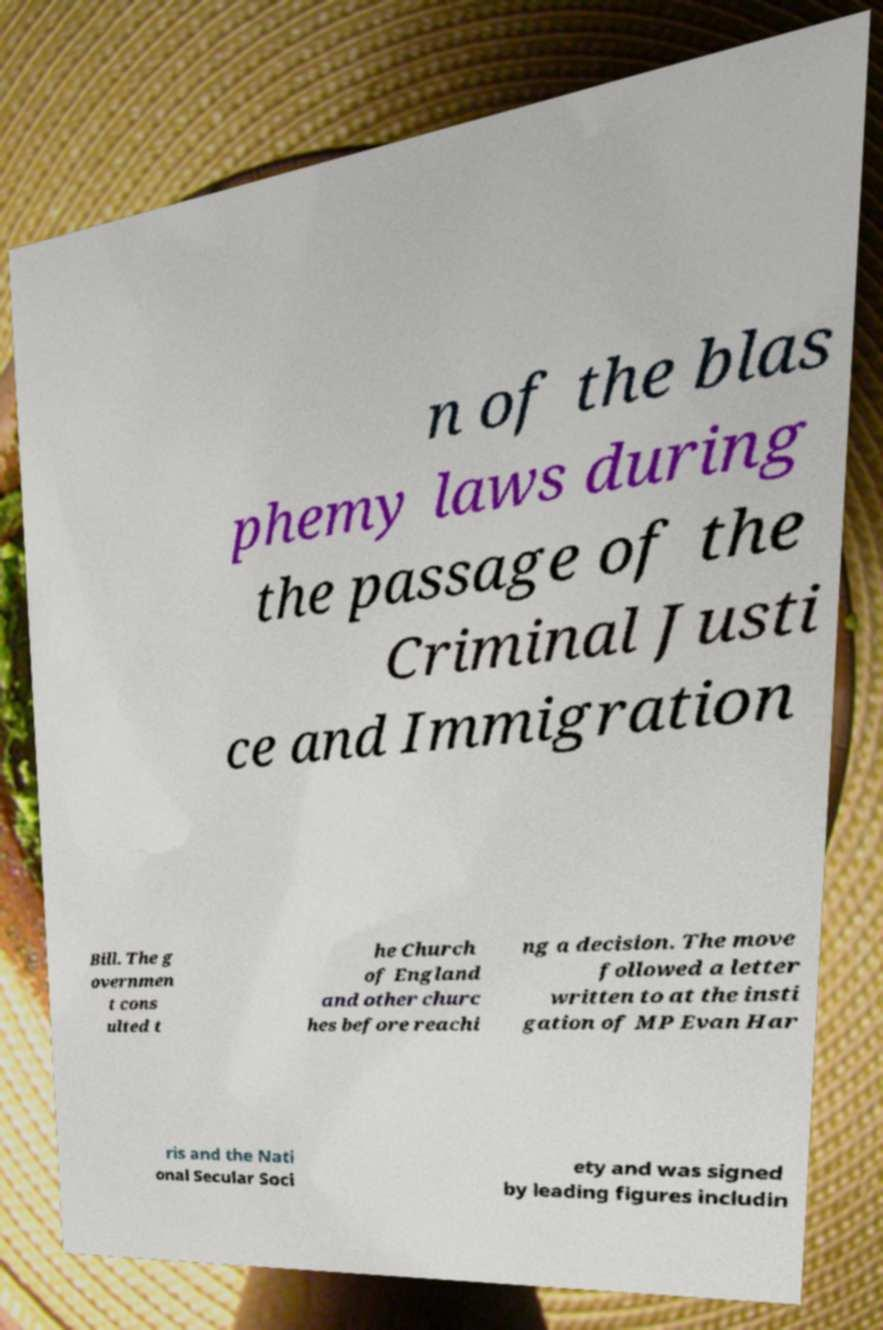For documentation purposes, I need the text within this image transcribed. Could you provide that? n of the blas phemy laws during the passage of the Criminal Justi ce and Immigration Bill. The g overnmen t cons ulted t he Church of England and other churc hes before reachi ng a decision. The move followed a letter written to at the insti gation of MP Evan Har ris and the Nati onal Secular Soci ety and was signed by leading figures includin 